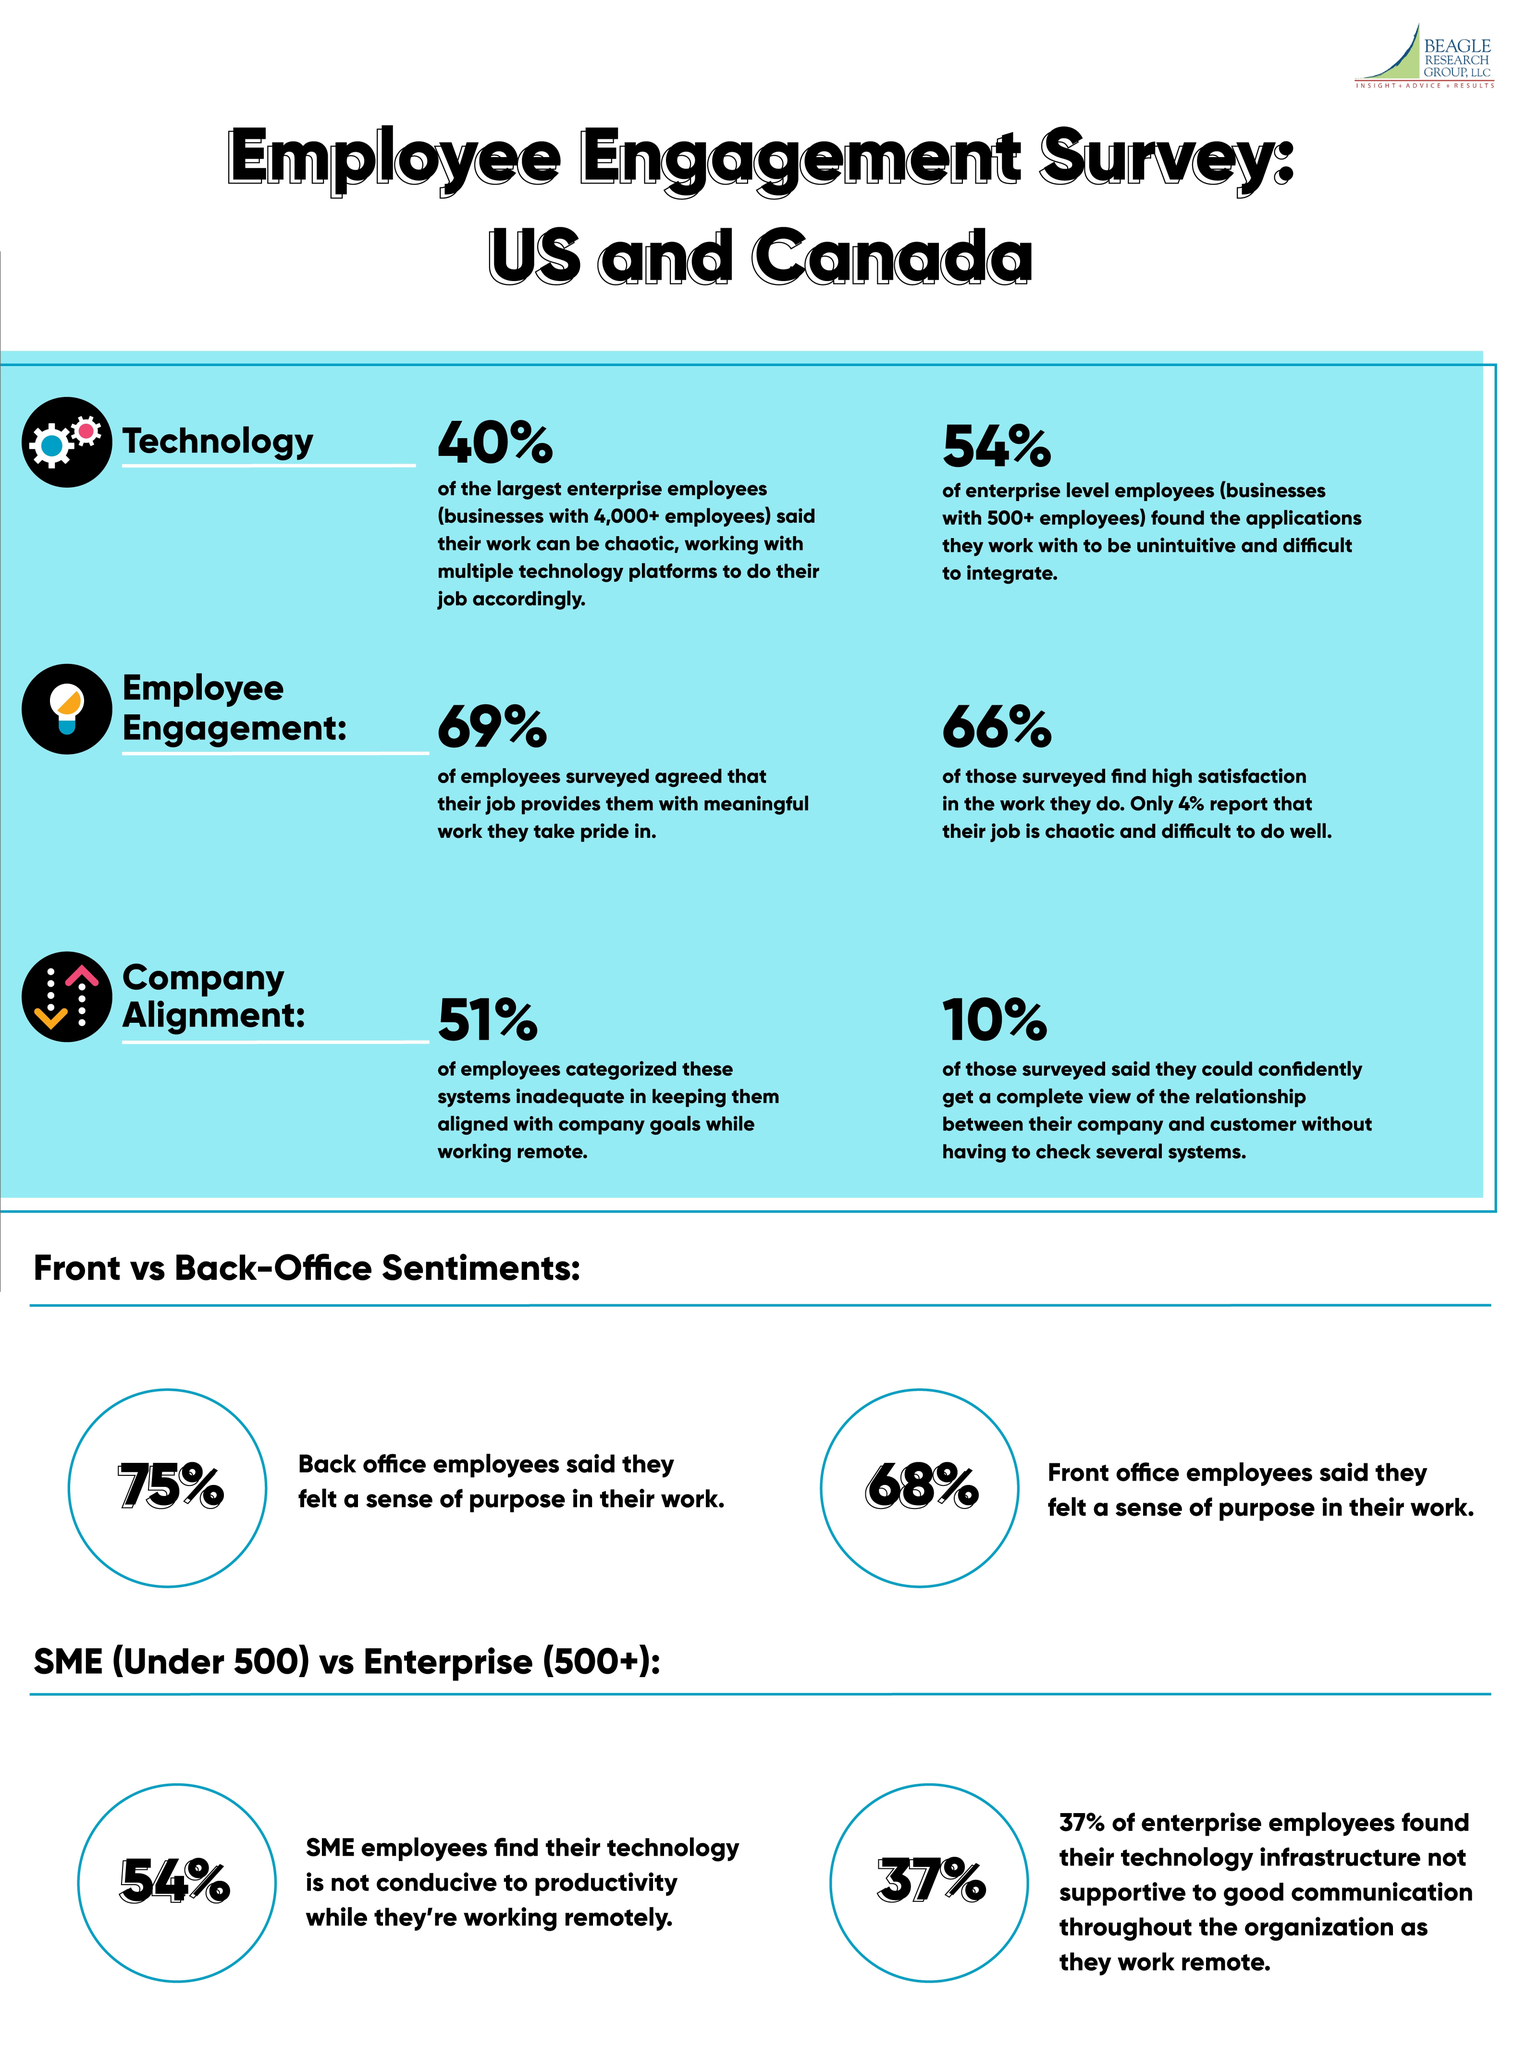Specify some key components in this picture. Sixty-three percent of employees believe that the technology they use to interact with each other is doing good. According to a survey of employees, 46% believe that the technology they are using is up to their expectations. A survey found that 25% of back office staff do not feel a sense of purpose in their work. According to a recent survey, 66% of employees express contentment with their work. According to the survey, 69% of employees feel proud about their work. 